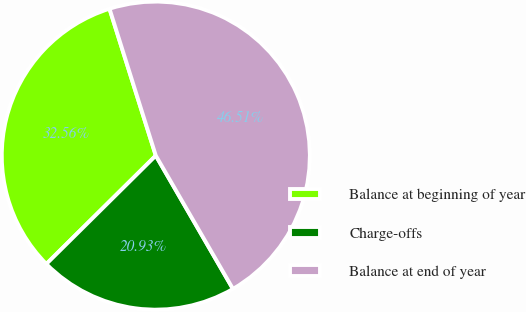Convert chart to OTSL. <chart><loc_0><loc_0><loc_500><loc_500><pie_chart><fcel>Balance at beginning of year<fcel>Charge-offs<fcel>Balance at end of year<nl><fcel>32.56%<fcel>20.93%<fcel>46.51%<nl></chart> 